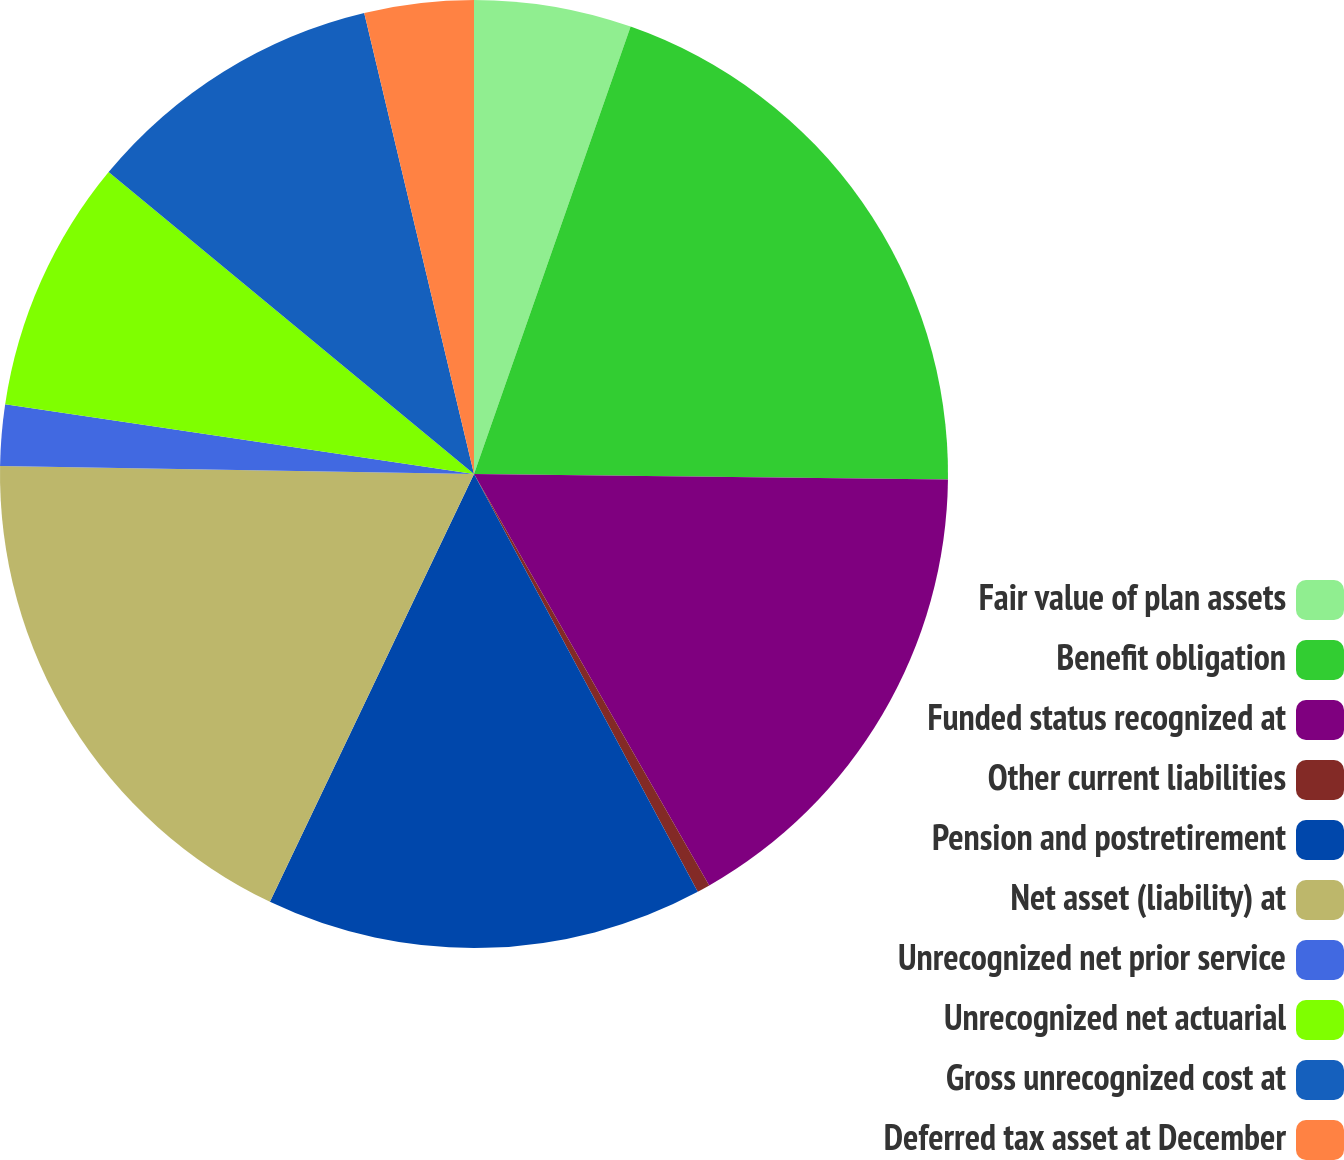Convert chart to OTSL. <chart><loc_0><loc_0><loc_500><loc_500><pie_chart><fcel>Fair value of plan assets<fcel>Benefit obligation<fcel>Funded status recognized at<fcel>Other current liabilities<fcel>Pension and postretirement<fcel>Net asset (liability) at<fcel>Unrecognized net prior service<fcel>Unrecognized net actuarial<fcel>Gross unrecognized cost at<fcel>Deferred tax asset at December<nl><fcel>5.36%<fcel>19.83%<fcel>16.55%<fcel>0.44%<fcel>14.91%<fcel>18.19%<fcel>2.08%<fcel>8.64%<fcel>10.29%<fcel>3.72%<nl></chart> 